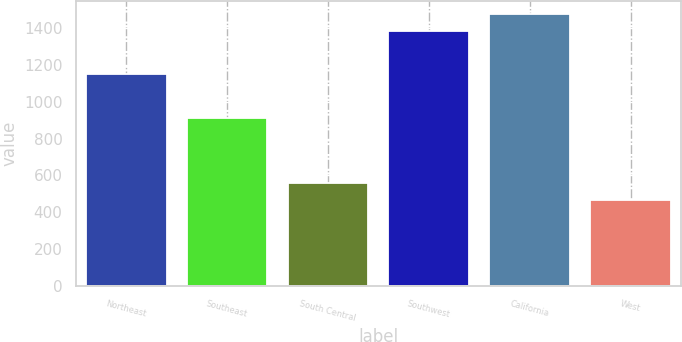Convert chart. <chart><loc_0><loc_0><loc_500><loc_500><bar_chart><fcel>Northeast<fcel>Southeast<fcel>South Central<fcel>Southwest<fcel>California<fcel>West<nl><fcel>1148.9<fcel>909.4<fcel>559.87<fcel>1382.8<fcel>1476.57<fcel>466.1<nl></chart> 